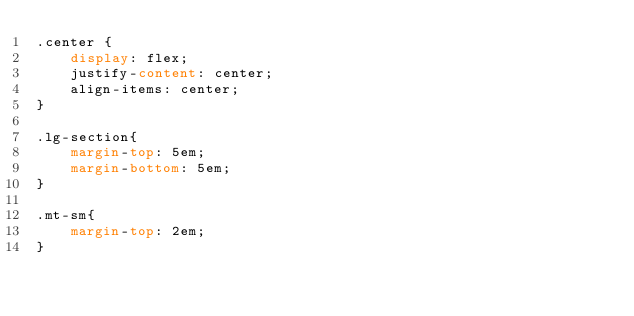Convert code to text. <code><loc_0><loc_0><loc_500><loc_500><_CSS_>.center {
    display: flex;
    justify-content: center;
    align-items: center;
}

.lg-section{
    margin-top: 5em;
    margin-bottom: 5em;
}

.mt-sm{
    margin-top: 2em;
}</code> 